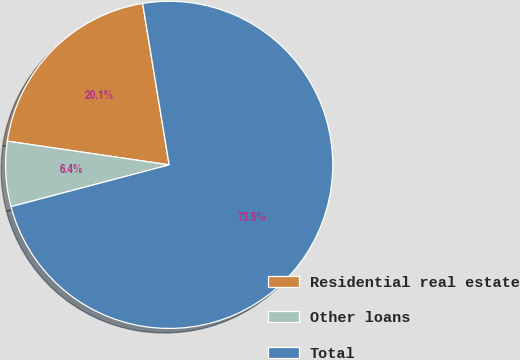Convert chart. <chart><loc_0><loc_0><loc_500><loc_500><pie_chart><fcel>Residential real estate<fcel>Other loans<fcel>Total<nl><fcel>20.09%<fcel>6.43%<fcel>73.48%<nl></chart> 